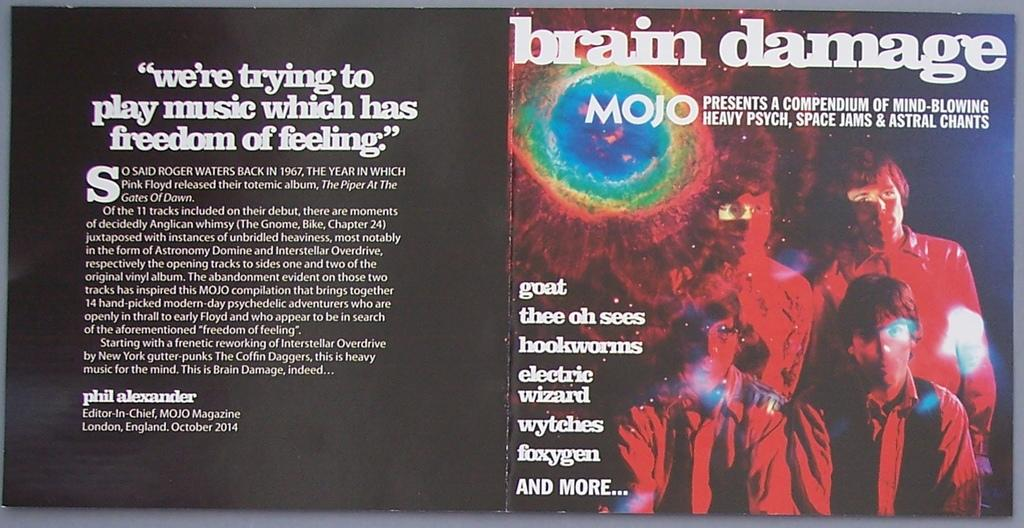Provide a one-sentence caption for the provided image. A music disc is open and titled brain damage. 